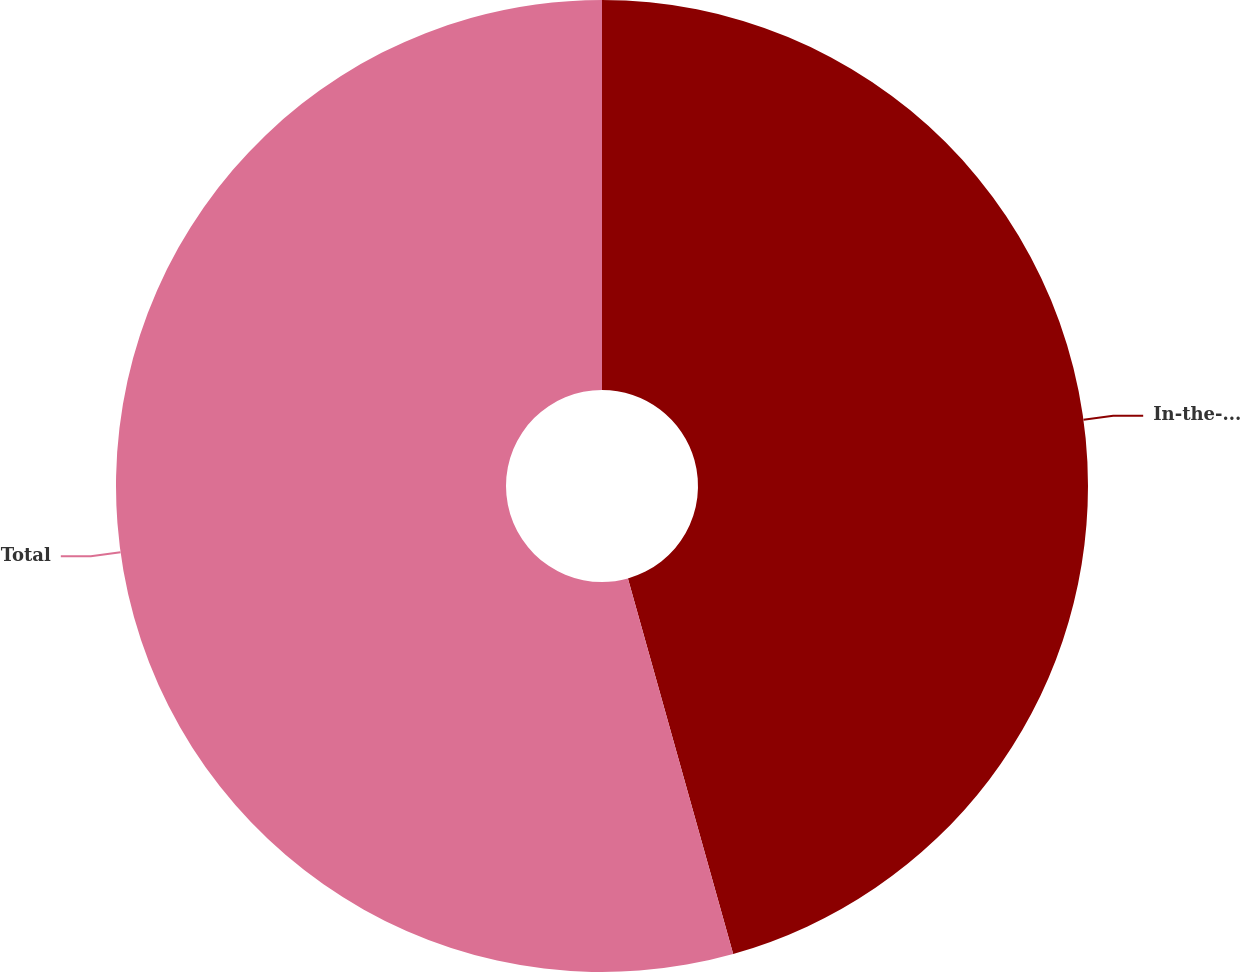<chart> <loc_0><loc_0><loc_500><loc_500><pie_chart><fcel>In-the-money<fcel>Total<nl><fcel>45.65%<fcel>54.35%<nl></chart> 